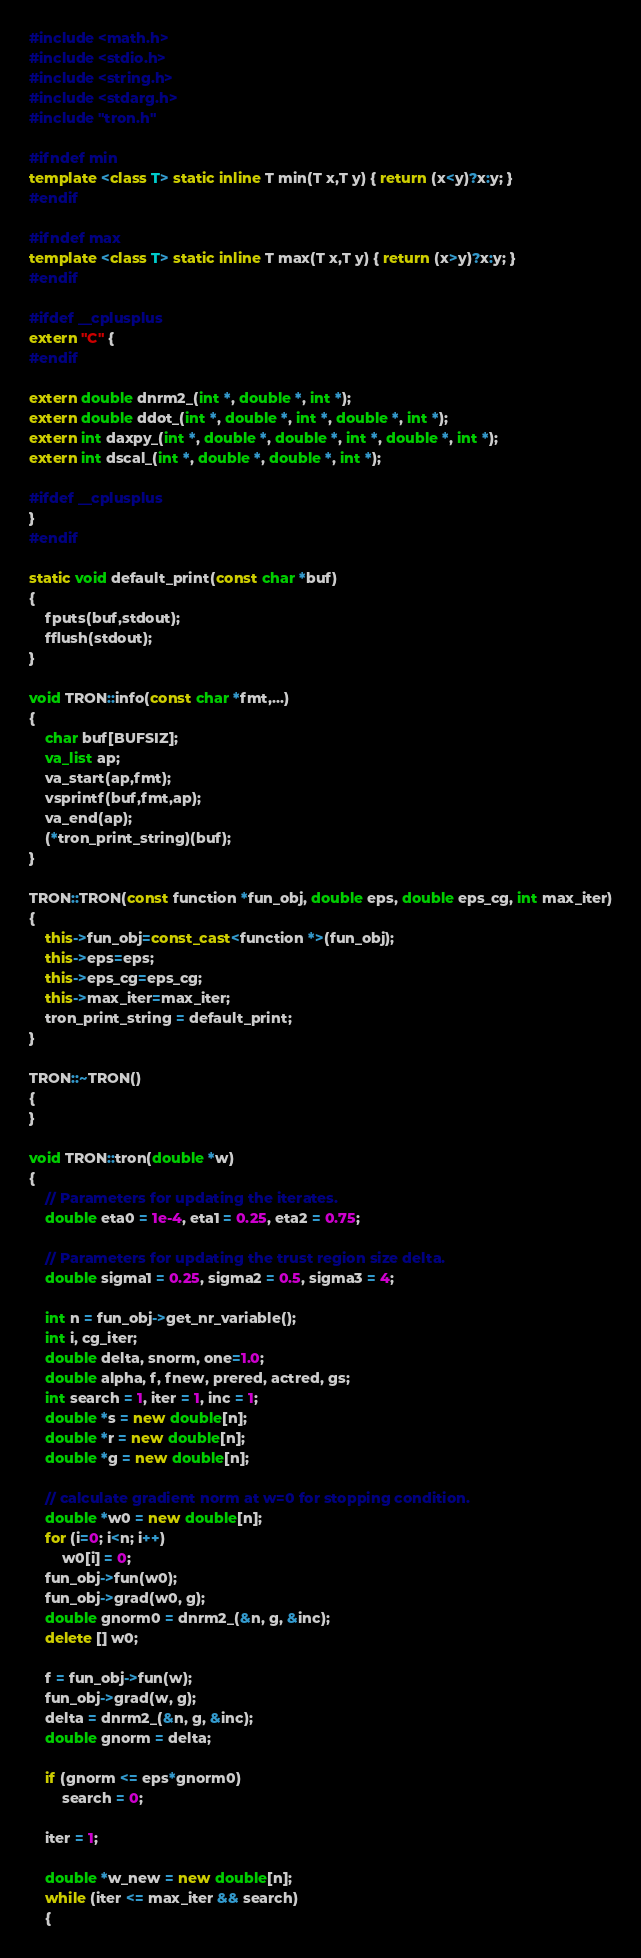<code> <loc_0><loc_0><loc_500><loc_500><_C++_>#include <math.h>
#include <stdio.h>
#include <string.h>
#include <stdarg.h>
#include "tron.h"

#ifndef min
template <class T> static inline T min(T x,T y) { return (x<y)?x:y; }
#endif

#ifndef max
template <class T> static inline T max(T x,T y) { return (x>y)?x:y; }
#endif

#ifdef __cplusplus
extern "C" {
#endif

extern double dnrm2_(int *, double *, int *);
extern double ddot_(int *, double *, int *, double *, int *);
extern int daxpy_(int *, double *, double *, int *, double *, int *);
extern int dscal_(int *, double *, double *, int *);

#ifdef __cplusplus
}
#endif

static void default_print(const char *buf)
{
	fputs(buf,stdout);
	fflush(stdout);
}

void TRON::info(const char *fmt,...)
{
	char buf[BUFSIZ];
	va_list ap;
	va_start(ap,fmt);
	vsprintf(buf,fmt,ap);
	va_end(ap);
	(*tron_print_string)(buf);
}

TRON::TRON(const function *fun_obj, double eps, double eps_cg, int max_iter)
{
	this->fun_obj=const_cast<function *>(fun_obj);
	this->eps=eps;
	this->eps_cg=eps_cg;
	this->max_iter=max_iter;
	tron_print_string = default_print;
}

TRON::~TRON()
{
}

void TRON::tron(double *w)
{
	// Parameters for updating the iterates.
	double eta0 = 1e-4, eta1 = 0.25, eta2 = 0.75;

	// Parameters for updating the trust region size delta.
	double sigma1 = 0.25, sigma2 = 0.5, sigma3 = 4;

	int n = fun_obj->get_nr_variable();
	int i, cg_iter;
	double delta, snorm, one=1.0;
	double alpha, f, fnew, prered, actred, gs;
	int search = 1, iter = 1, inc = 1;
	double *s = new double[n];
	double *r = new double[n];
	double *g = new double[n];

	// calculate gradient norm at w=0 for stopping condition.
	double *w0 = new double[n];
	for (i=0; i<n; i++)
		w0[i] = 0;
	fun_obj->fun(w0);
	fun_obj->grad(w0, g);
	double gnorm0 = dnrm2_(&n, g, &inc);
	delete [] w0;

	f = fun_obj->fun(w);
	fun_obj->grad(w, g);
	delta = dnrm2_(&n, g, &inc);
	double gnorm = delta;

	if (gnorm <= eps*gnorm0)
		search = 0;

	iter = 1;

	double *w_new = new double[n];
	while (iter <= max_iter && search)
	{</code> 